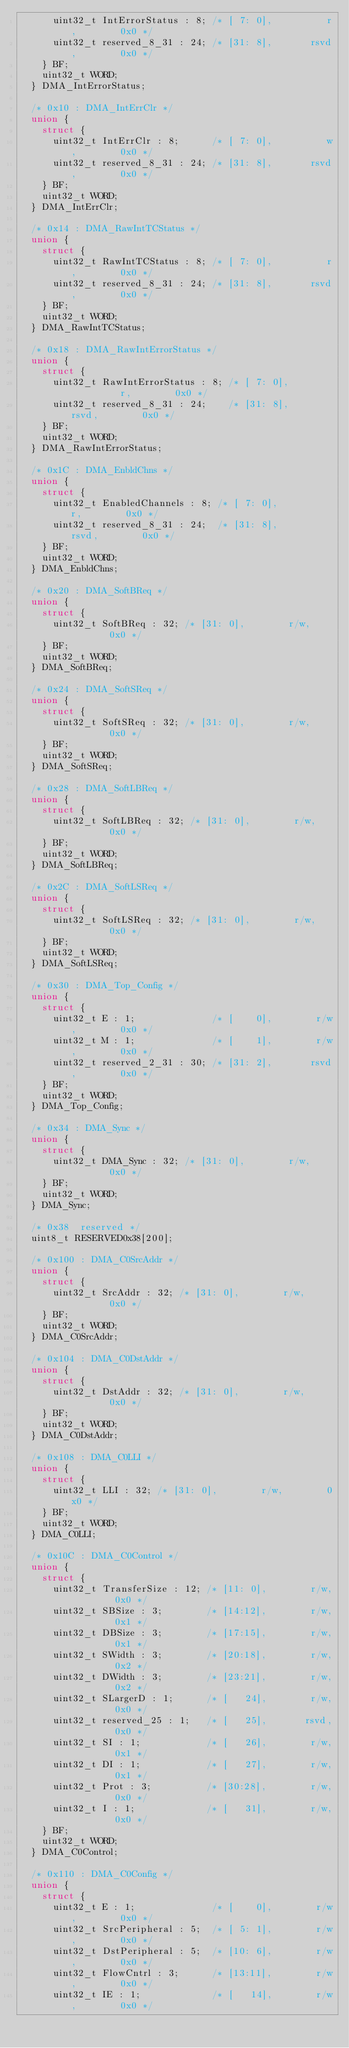<code> <loc_0><loc_0><loc_500><loc_500><_C_>      uint32_t IntErrorStatus : 8; /* [ 7: 0],          r,        0x0 */
      uint32_t reserved_8_31 : 24; /* [31: 8],       rsvd,        0x0 */
    } BF;
    uint32_t WORD;
  } DMA_IntErrorStatus;

  /* 0x10 : DMA_IntErrClr */
  union {
    struct {
      uint32_t IntErrClr : 8;      /* [ 7: 0],          w,        0x0 */
      uint32_t reserved_8_31 : 24; /* [31: 8],       rsvd,        0x0 */
    } BF;
    uint32_t WORD;
  } DMA_IntErrClr;

  /* 0x14 : DMA_RawIntTCStatus */
  union {
    struct {
      uint32_t RawIntTCStatus : 8; /* [ 7: 0],          r,        0x0 */
      uint32_t reserved_8_31 : 24; /* [31: 8],       rsvd,        0x0 */
    } BF;
    uint32_t WORD;
  } DMA_RawIntTCStatus;

  /* 0x18 : DMA_RawIntErrorStatus */
  union {
    struct {
      uint32_t RawIntErrorStatus : 8; /* [ 7: 0],          r,        0x0 */
      uint32_t reserved_8_31 : 24;    /* [31: 8],       rsvd,        0x0 */
    } BF;
    uint32_t WORD;
  } DMA_RawIntErrorStatus;

  /* 0x1C : DMA_EnbldChns */
  union {
    struct {
      uint32_t EnabledChannels : 8; /* [ 7: 0],          r,        0x0 */
      uint32_t reserved_8_31 : 24;  /* [31: 8],       rsvd,        0x0 */
    } BF;
    uint32_t WORD;
  } DMA_EnbldChns;

  /* 0x20 : DMA_SoftBReq */
  union {
    struct {
      uint32_t SoftBReq : 32; /* [31: 0],        r/w,        0x0 */
    } BF;
    uint32_t WORD;
  } DMA_SoftBReq;

  /* 0x24 : DMA_SoftSReq */
  union {
    struct {
      uint32_t SoftSReq : 32; /* [31: 0],        r/w,        0x0 */
    } BF;
    uint32_t WORD;
  } DMA_SoftSReq;

  /* 0x28 : DMA_SoftLBReq */
  union {
    struct {
      uint32_t SoftLBReq : 32; /* [31: 0],        r/w,        0x0 */
    } BF;
    uint32_t WORD;
  } DMA_SoftLBReq;

  /* 0x2C : DMA_SoftLSReq */
  union {
    struct {
      uint32_t SoftLSReq : 32; /* [31: 0],        r/w,        0x0 */
    } BF;
    uint32_t WORD;
  } DMA_SoftLSReq;

  /* 0x30 : DMA_Top_Config */
  union {
    struct {
      uint32_t E : 1;              /* [    0],        r/w,        0x0 */
      uint32_t M : 1;              /* [    1],        r/w,        0x0 */
      uint32_t reserved_2_31 : 30; /* [31: 2],       rsvd,        0x0 */
    } BF;
    uint32_t WORD;
  } DMA_Top_Config;

  /* 0x34 : DMA_Sync */
  union {
    struct {
      uint32_t DMA_Sync : 32; /* [31: 0],        r/w,        0x0 */
    } BF;
    uint32_t WORD;
  } DMA_Sync;

  /* 0x38  reserved */
  uint8_t RESERVED0x38[200];

  /* 0x100 : DMA_C0SrcAddr */
  union {
    struct {
      uint32_t SrcAddr : 32; /* [31: 0],        r/w,        0x0 */
    } BF;
    uint32_t WORD;
  } DMA_C0SrcAddr;

  /* 0x104 : DMA_C0DstAddr */
  union {
    struct {
      uint32_t DstAddr : 32; /* [31: 0],        r/w,        0x0 */
    } BF;
    uint32_t WORD;
  } DMA_C0DstAddr;

  /* 0x108 : DMA_C0LLI */
  union {
    struct {
      uint32_t LLI : 32; /* [31: 0],        r/w,        0x0 */
    } BF;
    uint32_t WORD;
  } DMA_C0LLI;

  /* 0x10C : DMA_C0Control */
  union {
    struct {
      uint32_t TransferSize : 12; /* [11: 0],        r/w,        0x0 */
      uint32_t SBSize : 3;        /* [14:12],        r/w,        0x1 */
      uint32_t DBSize : 3;        /* [17:15],        r/w,        0x1 */
      uint32_t SWidth : 3;        /* [20:18],        r/w,        0x2 */
      uint32_t DWidth : 3;        /* [23:21],        r/w,        0x2 */
      uint32_t SLargerD : 1;      /* [   24],        r/w,        0x0 */
      uint32_t reserved_25 : 1;   /* [   25],       rsvd,        0x0 */
      uint32_t SI : 1;            /* [   26],        r/w,        0x1 */
      uint32_t DI : 1;            /* [   27],        r/w,        0x1 */
      uint32_t Prot : 3;          /* [30:28],        r/w,        0x0 */
      uint32_t I : 1;             /* [   31],        r/w,        0x0 */
    } BF;
    uint32_t WORD;
  } DMA_C0Control;

  /* 0x110 : DMA_C0Config */
  union {
    struct {
      uint32_t E : 1;              /* [    0],        r/w,        0x0 */
      uint32_t SrcPeripheral : 5;  /* [ 5: 1],        r/w,        0x0 */
      uint32_t DstPeripheral : 5;  /* [10: 6],        r/w,        0x0 */
      uint32_t FlowCntrl : 3;      /* [13:11],        r/w,        0x0 */
      uint32_t IE : 1;             /* [   14],        r/w,        0x0 */</code> 